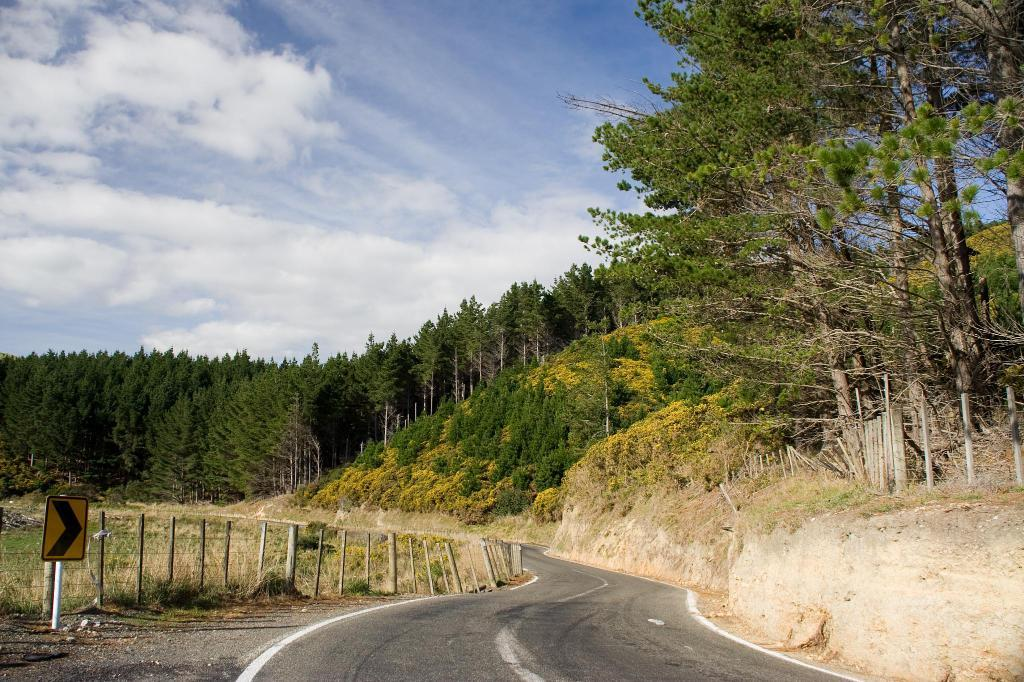What is the main feature of the image? There is a road in the image. What else can be seen along the road? A: There are poles and a pole with a board in the image. What might be used for safety or guidance along the road? The railing is visible in the image. What type of trees are present in the image? There are green and yellow trees in the image. What is visible in the background of the image? The sky is visible in the background of the image. How much salt is being used to season the trees in the image? There is no salt being used to season the trees in the image; the trees are naturally green and yellow. 